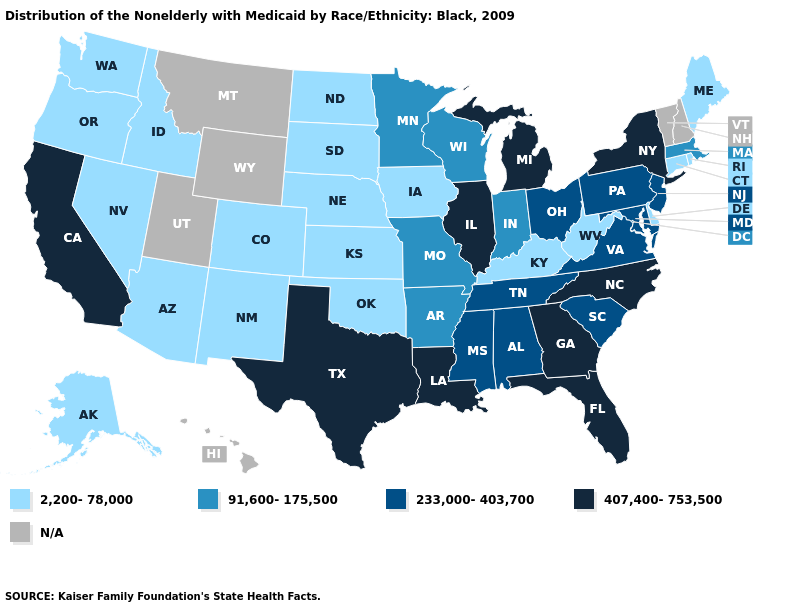Name the states that have a value in the range 233,000-403,700?
Concise answer only. Alabama, Maryland, Mississippi, New Jersey, Ohio, Pennsylvania, South Carolina, Tennessee, Virginia. Name the states that have a value in the range 2,200-78,000?
Write a very short answer. Alaska, Arizona, Colorado, Connecticut, Delaware, Idaho, Iowa, Kansas, Kentucky, Maine, Nebraska, Nevada, New Mexico, North Dakota, Oklahoma, Oregon, Rhode Island, South Dakota, Washington, West Virginia. What is the highest value in states that border Connecticut?
Keep it brief. 407,400-753,500. Does the map have missing data?
Short answer required. Yes. Name the states that have a value in the range 2,200-78,000?
Keep it brief. Alaska, Arizona, Colorado, Connecticut, Delaware, Idaho, Iowa, Kansas, Kentucky, Maine, Nebraska, Nevada, New Mexico, North Dakota, Oklahoma, Oregon, Rhode Island, South Dakota, Washington, West Virginia. What is the highest value in the USA?
Keep it brief. 407,400-753,500. What is the lowest value in the South?
Short answer required. 2,200-78,000. Which states have the highest value in the USA?
Answer briefly. California, Florida, Georgia, Illinois, Louisiana, Michigan, New York, North Carolina, Texas. What is the value of Massachusetts?
Concise answer only. 91,600-175,500. Among the states that border Nevada , which have the lowest value?
Be succinct. Arizona, Idaho, Oregon. Among the states that border Pennsylvania , does New York have the highest value?
Answer briefly. Yes. Does Nevada have the highest value in the USA?
Concise answer only. No. Does Texas have the highest value in the USA?
Give a very brief answer. Yes. Name the states that have a value in the range 2,200-78,000?
Keep it brief. Alaska, Arizona, Colorado, Connecticut, Delaware, Idaho, Iowa, Kansas, Kentucky, Maine, Nebraska, Nevada, New Mexico, North Dakota, Oklahoma, Oregon, Rhode Island, South Dakota, Washington, West Virginia. 